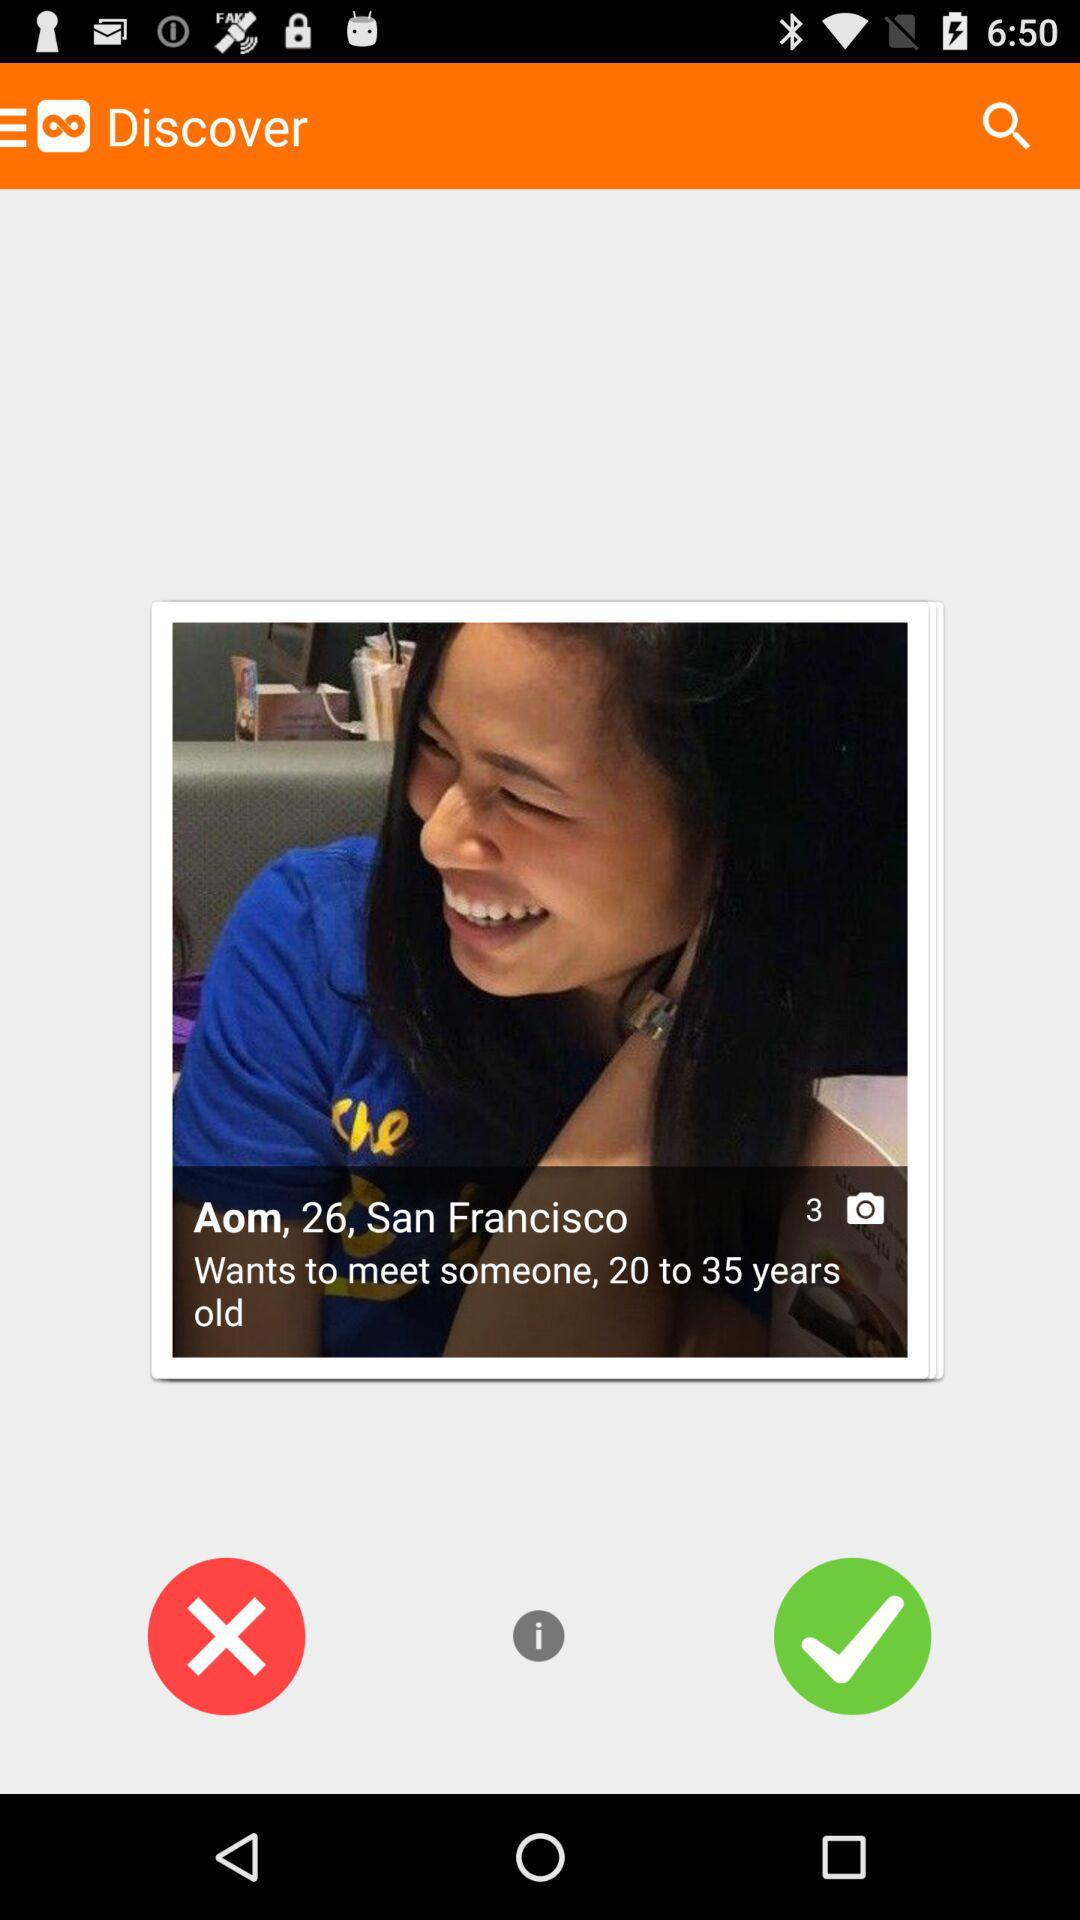What is the age of Aom? The age of Aom is 26 years. 